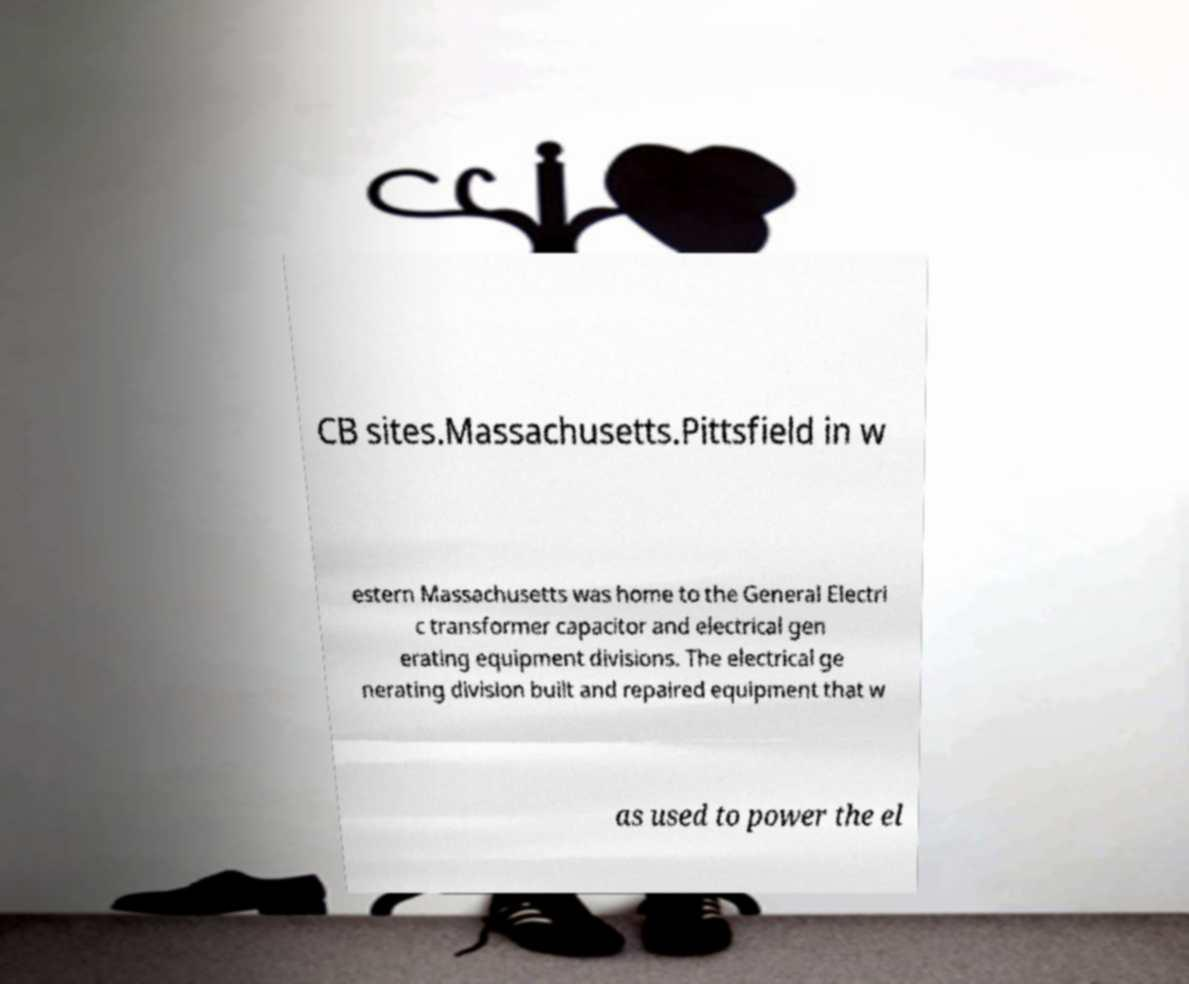I need the written content from this picture converted into text. Can you do that? CB sites.Massachusetts.Pittsfield in w estern Massachusetts was home to the General Electri c transformer capacitor and electrical gen erating equipment divisions. The electrical ge nerating division built and repaired equipment that w as used to power the el 